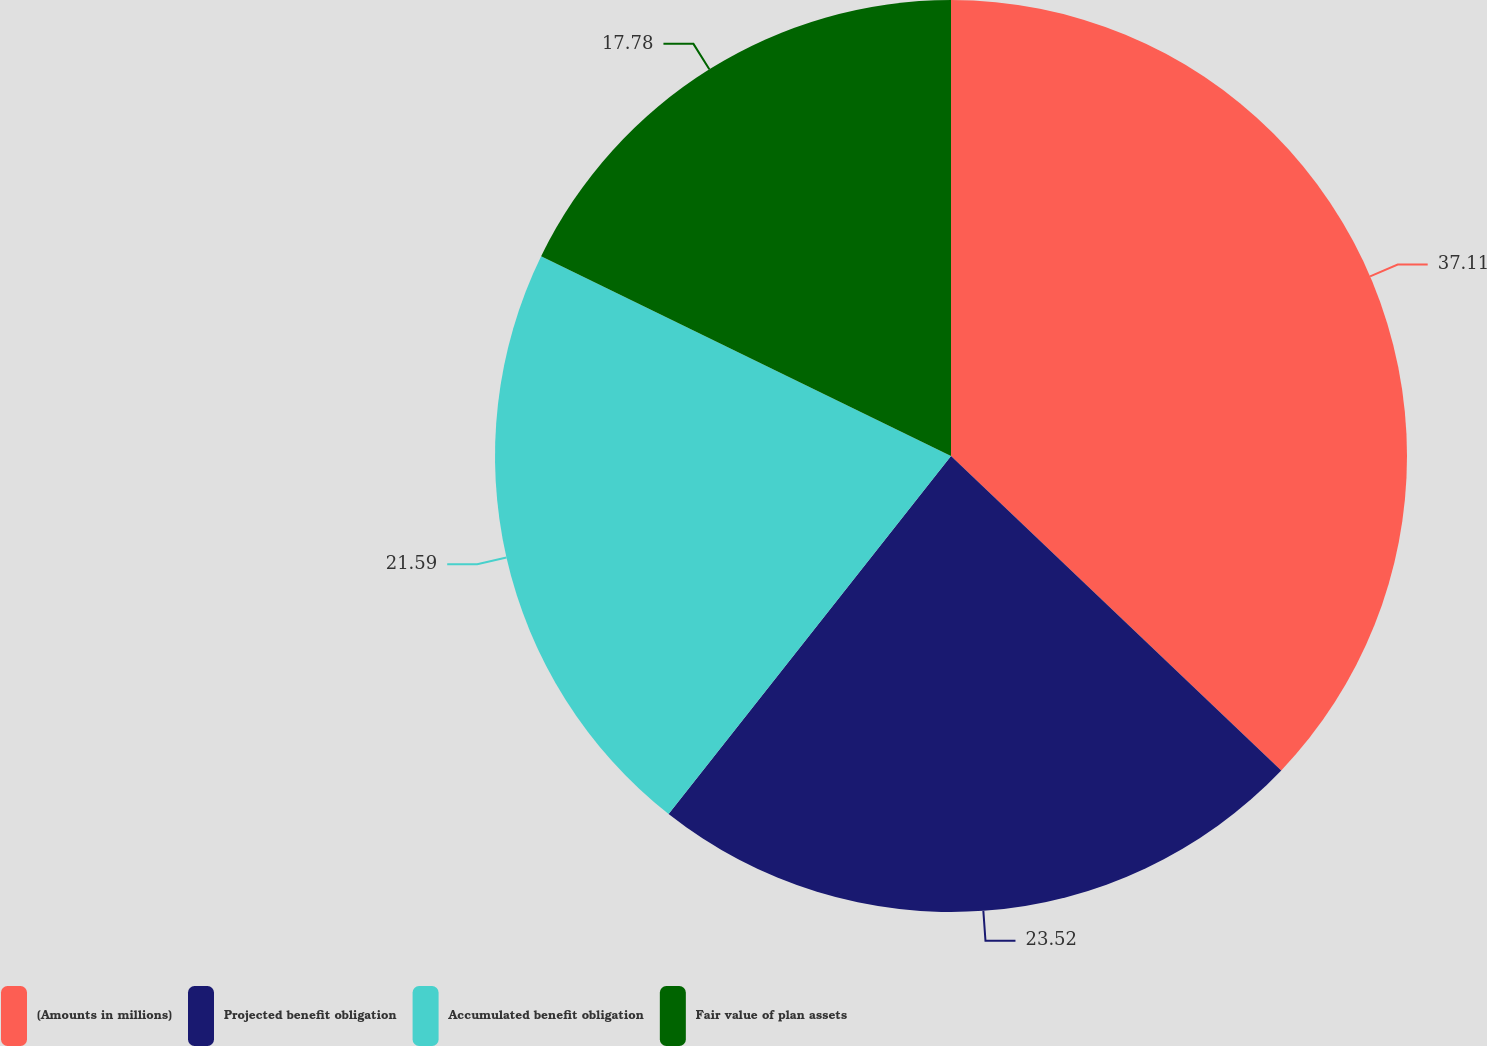Convert chart to OTSL. <chart><loc_0><loc_0><loc_500><loc_500><pie_chart><fcel>(Amounts in millions)<fcel>Projected benefit obligation<fcel>Accumulated benefit obligation<fcel>Fair value of plan assets<nl><fcel>37.11%<fcel>23.52%<fcel>21.59%<fcel>17.78%<nl></chart> 